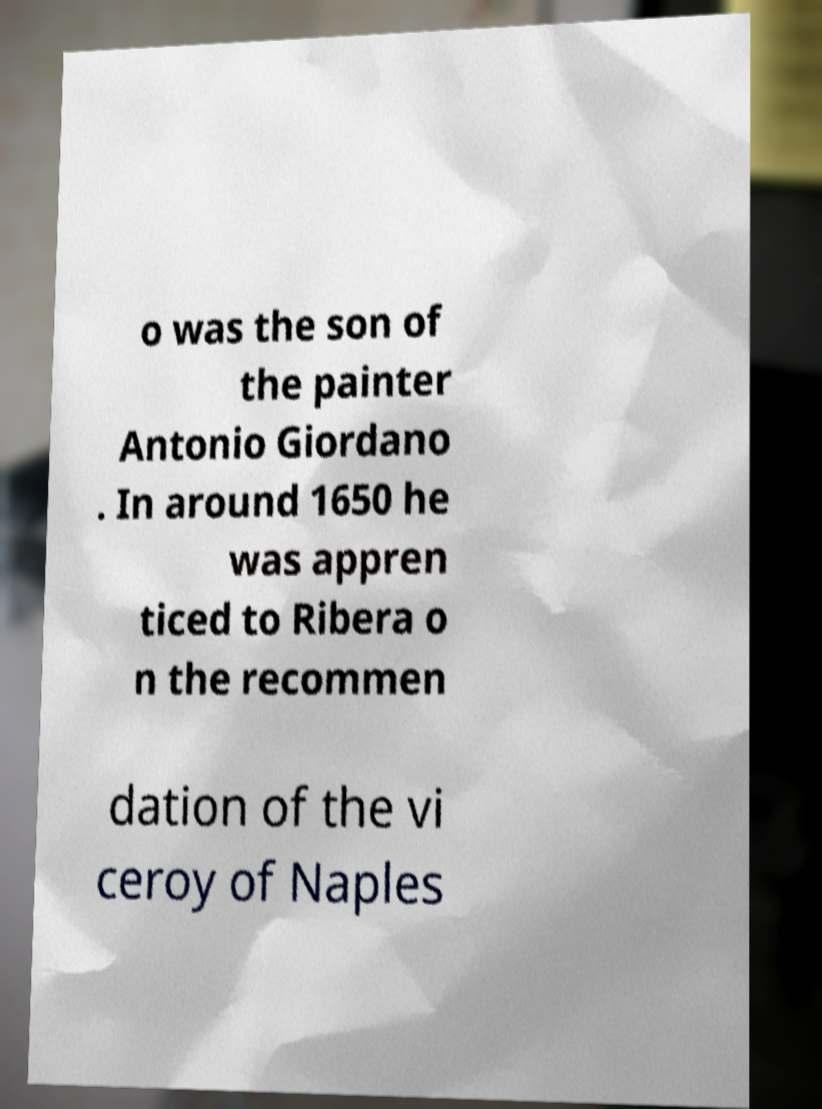Please identify and transcribe the text found in this image. o was the son of the painter Antonio Giordano . In around 1650 he was appren ticed to Ribera o n the recommen dation of the vi ceroy of Naples 